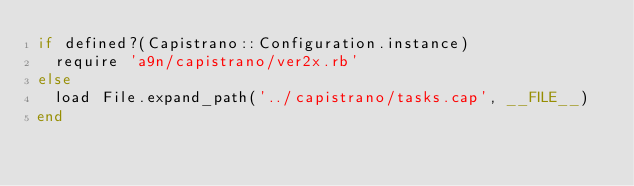<code> <loc_0><loc_0><loc_500><loc_500><_Ruby_>if defined?(Capistrano::Configuration.instance)
  require 'a9n/capistrano/ver2x.rb'
else
  load File.expand_path('../capistrano/tasks.cap', __FILE__)
end
</code> 